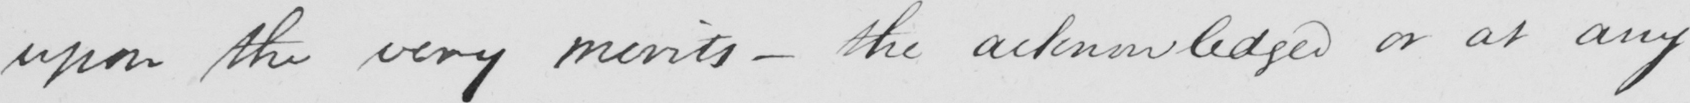Please provide the text content of this handwritten line. upon the very merits  _  the acknowledged or at any 